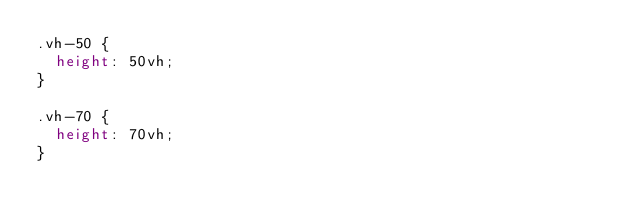Convert code to text. <code><loc_0><loc_0><loc_500><loc_500><_CSS_>.vh-50 {
	height: 50vh;
}

.vh-70 {
	height: 70vh;
}</code> 